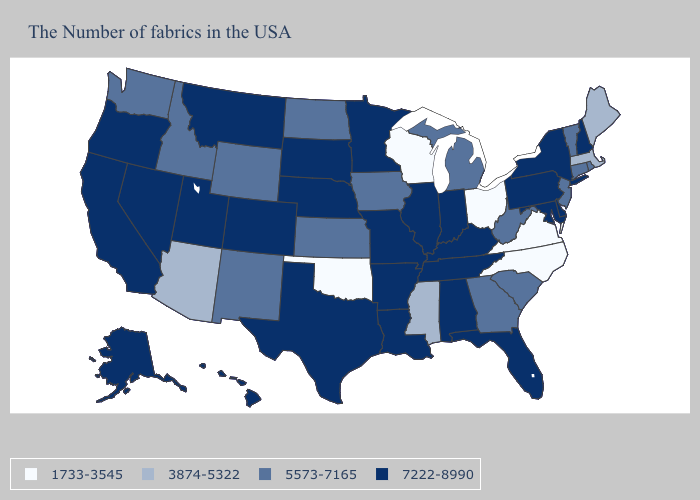Which states hav the highest value in the Northeast?
Concise answer only. New Hampshire, New York, Pennsylvania. Does Georgia have the highest value in the USA?
Write a very short answer. No. Name the states that have a value in the range 3874-5322?
Concise answer only. Maine, Massachusetts, Mississippi, Arizona. Among the states that border Vermont , which have the highest value?
Keep it brief. New Hampshire, New York. What is the lowest value in the Northeast?
Quick response, please. 3874-5322. Among the states that border Michigan , which have the lowest value?
Write a very short answer. Ohio, Wisconsin. What is the value of Wisconsin?
Quick response, please. 1733-3545. Name the states that have a value in the range 5573-7165?
Be succinct. Rhode Island, Vermont, Connecticut, New Jersey, South Carolina, West Virginia, Georgia, Michigan, Iowa, Kansas, North Dakota, Wyoming, New Mexico, Idaho, Washington. Among the states that border New York , which have the highest value?
Short answer required. Pennsylvania. Does the first symbol in the legend represent the smallest category?
Concise answer only. Yes. Name the states that have a value in the range 3874-5322?
Answer briefly. Maine, Massachusetts, Mississippi, Arizona. Name the states that have a value in the range 3874-5322?
Give a very brief answer. Maine, Massachusetts, Mississippi, Arizona. Name the states that have a value in the range 7222-8990?
Be succinct. New Hampshire, New York, Delaware, Maryland, Pennsylvania, Florida, Kentucky, Indiana, Alabama, Tennessee, Illinois, Louisiana, Missouri, Arkansas, Minnesota, Nebraska, Texas, South Dakota, Colorado, Utah, Montana, Nevada, California, Oregon, Alaska, Hawaii. What is the value of Maryland?
Quick response, please. 7222-8990. What is the value of Arkansas?
Give a very brief answer. 7222-8990. 